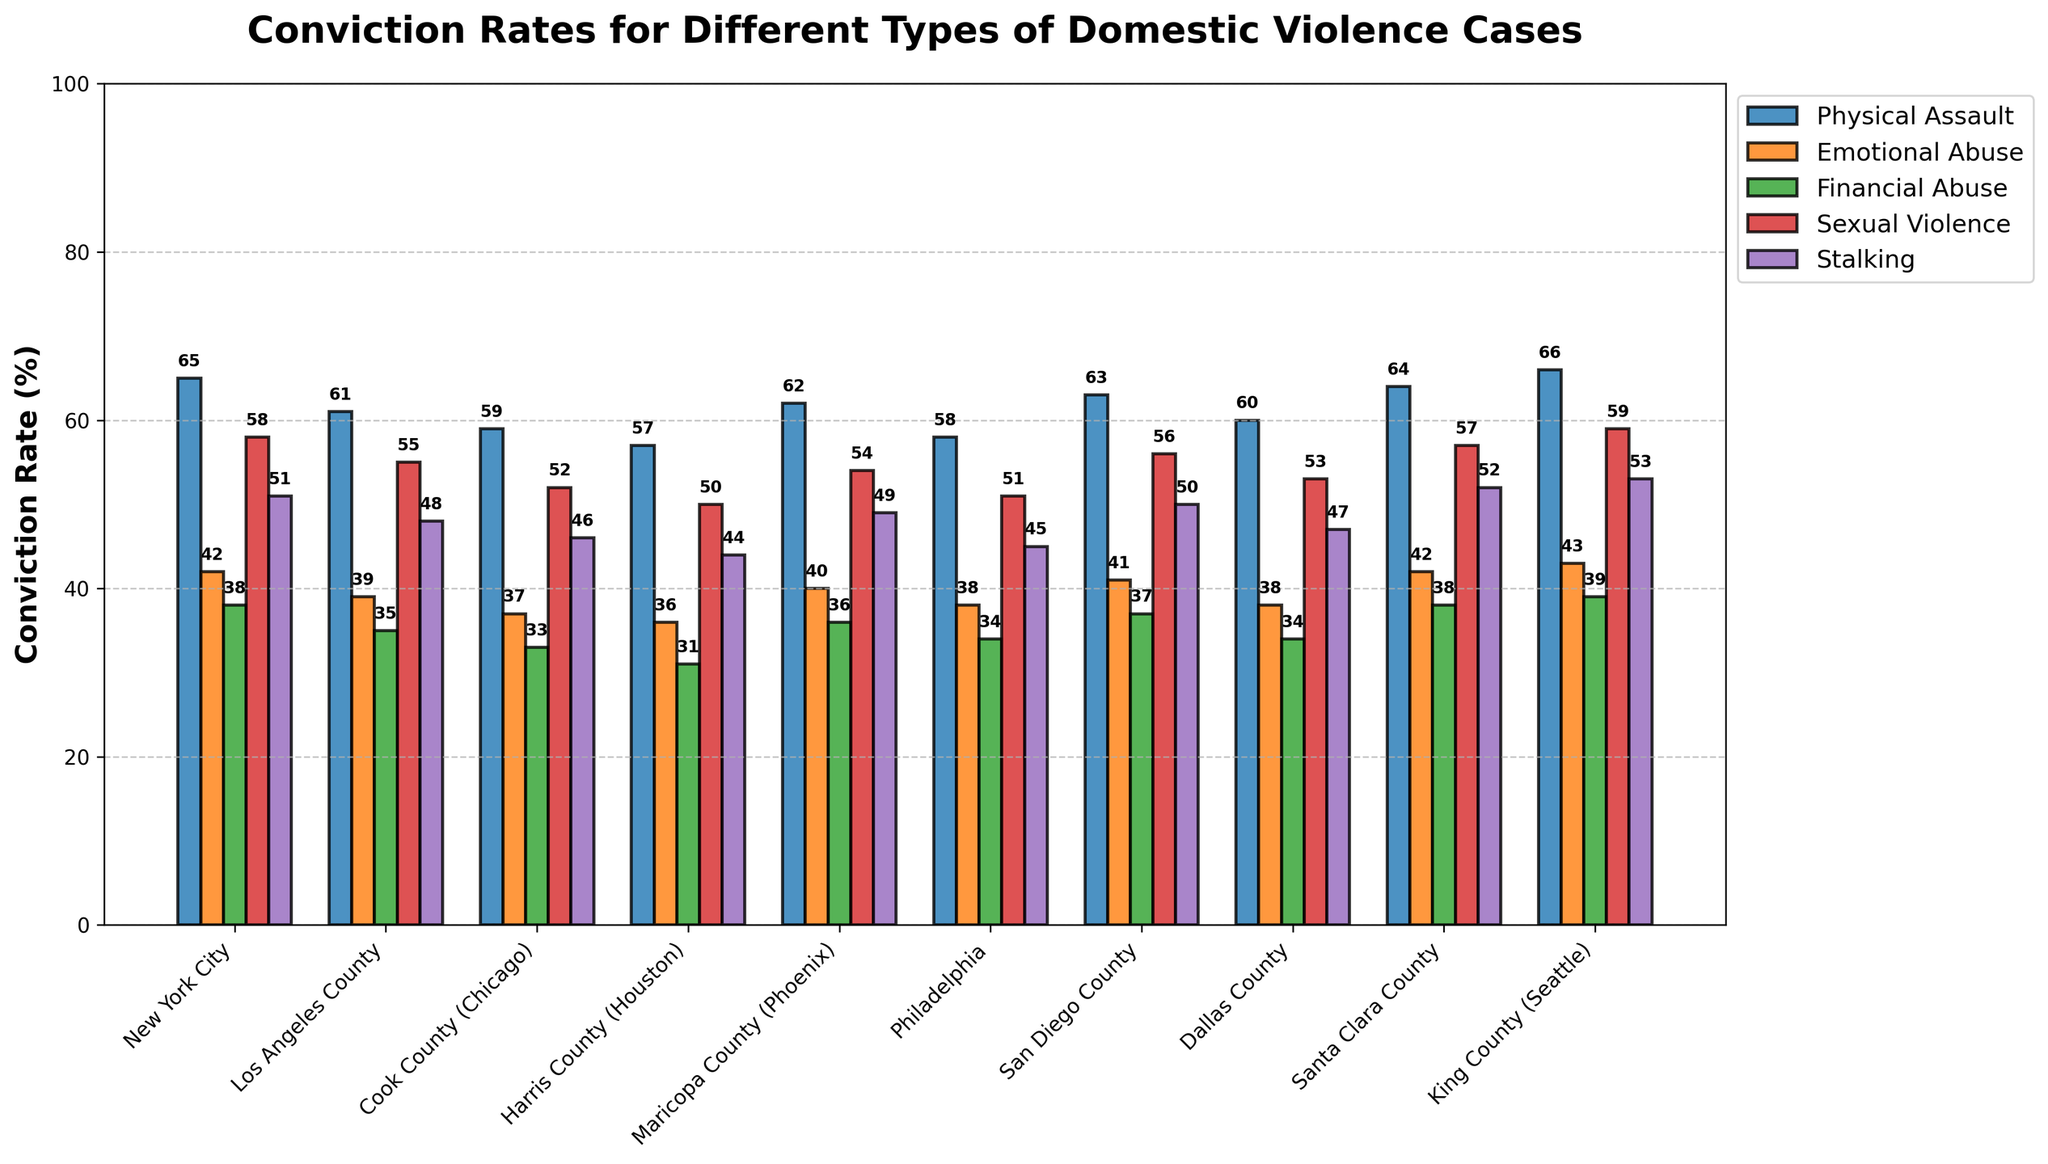What is the conviction rate for Physical Assault in King County (Seattle)? Locate the bar corresponding to Physical Assault in King County (Seattle). The height of the bar represents the conviction rate.
Answer: 66% Which jurisdiction has the highest conviction rate for Sexual Violence? Compare the heights of the bars representing Sexual Violence across all jurisdictions. The jurisdiction with the tallest bar has the highest conviction rate.
Answer: King County (Seattle) How does the conviction rate for Financial Abuse in Los Angeles County compare to that of Maricopa County (Phoenix)? Identify the bars representing Financial Abuse for Los Angeles County and Maricopa County (Phoenix). Compare their heights to determine which is taller.
Answer: Los Angeles County has a higher rate (35% vs 36%) What is the average conviction rate for Emotional Abuse in all jurisdictions? Sum the conviction rates for Emotional Abuse across all jurisdictions (42 + 39 + 37 + 36 + 40 + 38 + 41 + 38 + 42 + 43) and divide by the number of jurisdictions (10).
Answer: 39.6% Which jurisdiction has the lowest conviction rate for Physical Assault? Compare the heights of the bars representing Physical Assault across all jurisdictions. The jurisdiction with the shortest bar has the lowest conviction rate.
Answer: Harris County (Houston) What is the difference in conviction rates for Stalking between San Diego County and Philadelphia? Find and compare the heights of the bars representing Stalking for San Diego County and Philadelphia. Calculate the difference (50 - 45).
Answer: 5% Visualize the conviction rates for each type of domestic violence in Santa Clara County. Which type has the second-highest conviction rate? Look at the heights of the bars for each type of domestic violence in Santa Clara County. Rank them to find which one is the second highest.
Answer: Stalking (52%) How does the average conviction rate for Physical Assault compare to that for Sexual Violence across all jurisdictions? Calculate the average conviction rate for Physical Assault (sum: 615, avg: 615/10 = 61.5%) and Sexual Violence (sum: 505, avg: 505/10 = 50.5%). Compare the two averages.
Answer: Physical Assault has a higher average rate What are the overall trends in conviction rates across different jurisdictions for Emotional Abuse? Observe the lengths of the bars for Emotional Abuse. Note any patterns or outliers in the bar heights across jurisdictions.
Answer: Generally low across jurisdictions, highest in King County (43%) Identify the jurisdiction with the most consistent conviction rates across all types of domestic violence cases. Compare the fluctuations in bar heights for each jurisdiction to determine which has the least variation across all offense types.
Answer: Santa Clara County 